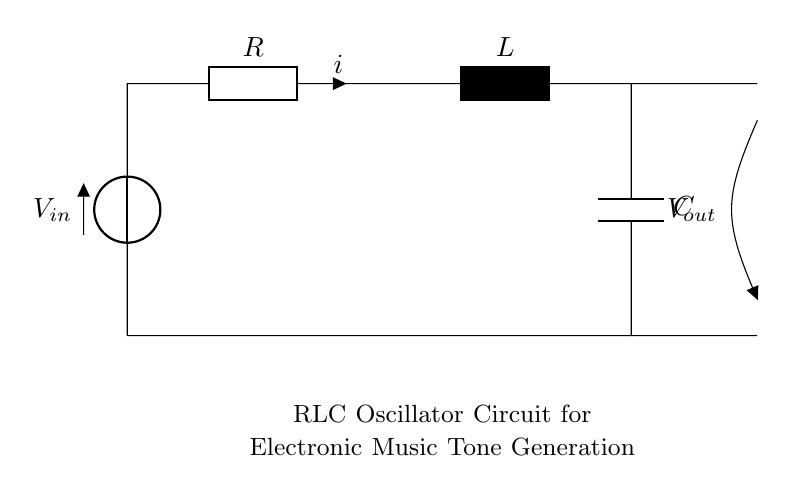What is the input voltage of this circuit? The input voltage is represented by the voltage source labeled V_in, which provides the electrical potential needed for the circuit to operate.
Answer: V_in What is the total current flowing through the resistor? The total current flowing through the resistor is denoted by the variable 'i', indicating the flow of electric charge through that component.
Answer: i Which components are connected in series in this circuit? The components connected in series in the RLC circuit are the resistor, inductor, and capacitor, forming a single pathway for the current to pass through sequentially.
Answer: Resistor, Inductor, Capacitor What type of circuit is illustrated here? The circuit shown is classified as an RLC oscillator circuit, which is specifically designed to generate oscillating signals used in tone generation for electronic music instruments.
Answer: RLC oscillator What is the role of the inductor in this circuit? The inductor in the circuit serves to store energy in a magnetic field when electric current passes through it, contributing to the oscillatory behavior of the circuit.
Answer: Energy storage How does the output voltage relate to the input voltage in this circuit? The output voltage, labeled V_out, is taken across the capacitor, and its magnitude can vary based on the circuit’s oscillation and component values compared to the input voltage.
Answer: V_out What happens to the oscillation frequency if the inductor value is increased? If the value of the inductor is increased, the oscillation frequency will decrease, as the inductance and the total circuit impedance influence the frequency of oscillation in an RLC circuit.
Answer: Decreases 